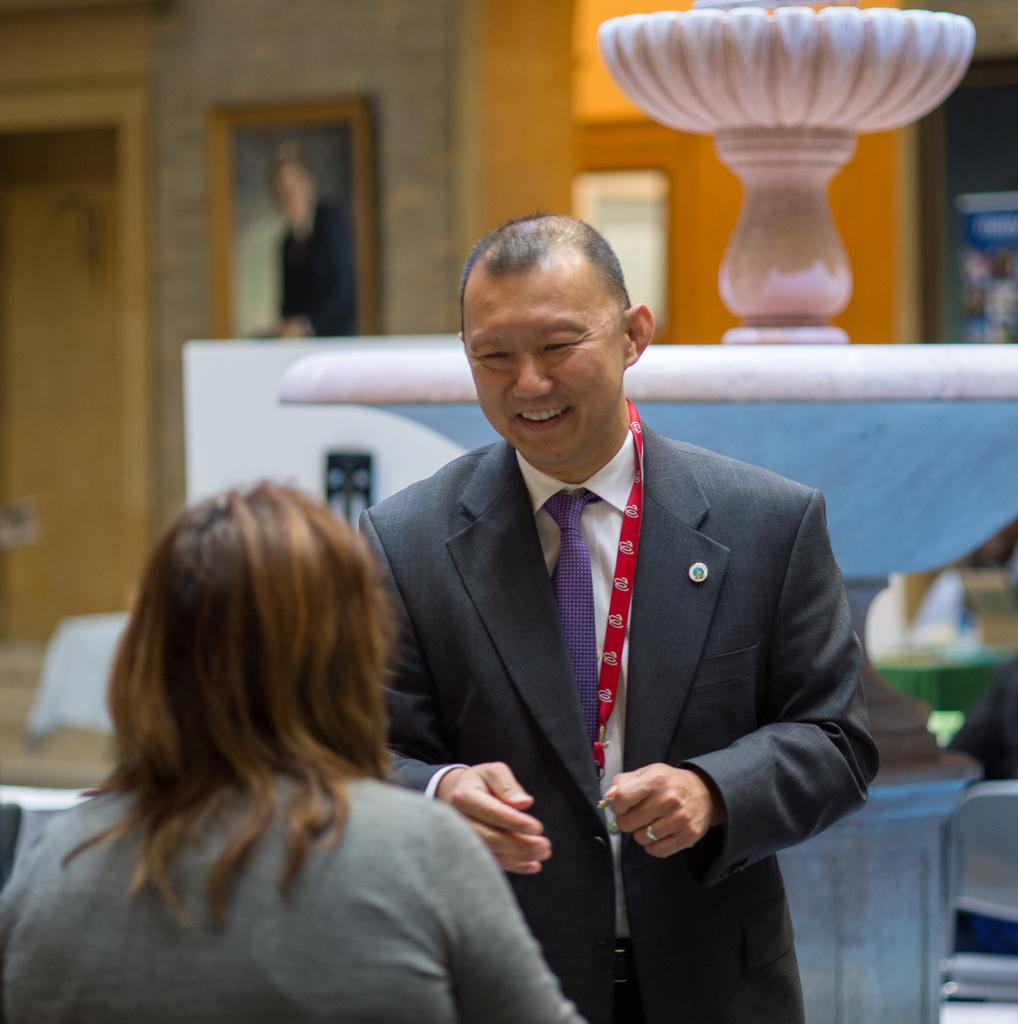What is the woman doing in the image? The woman is sitting in the image. What is the man doing in the image? The man is standing in the image. What can be seen in the background of the image? There is a fountain and a wall in the background of the image. Can you describe the photograph on the wall? The photograph on the wall is blurred. What type of art can be seen being created with a hose in the image? There is no art or hose present in the image. How does the woman rub the man's back in the image? The woman is sitting, not rubbing the man's back, in the image. 